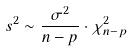<formula> <loc_0><loc_0><loc_500><loc_500>s ^ { 2 } \sim \frac { \sigma ^ { 2 } } { n - p } \cdot \chi _ { n - p } ^ { 2 }</formula> 